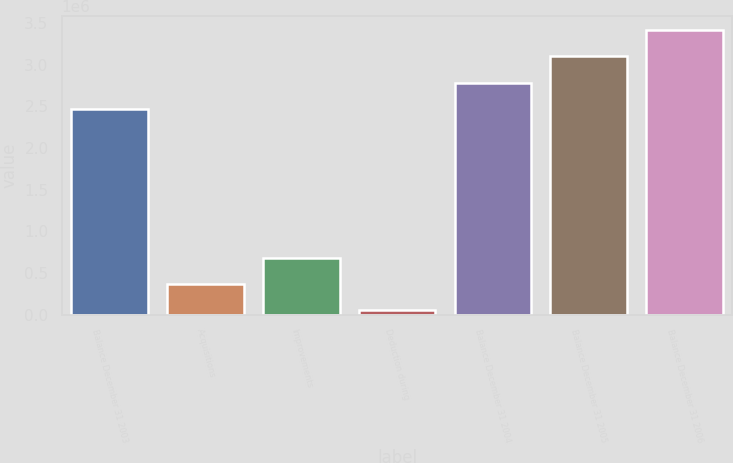<chart> <loc_0><loc_0><loc_500><loc_500><bar_chart><fcel>Balance December 31 2003<fcel>Acquisitions<fcel>Improvements<fcel>Deduction during<fcel>Balance December 31 2004<fcel>Balance December 31 2005<fcel>Balance December 31 2006<nl><fcel>2.47015e+06<fcel>368959<fcel>683992<fcel>53926<fcel>2.78518e+06<fcel>3.10022e+06<fcel>3.41525e+06<nl></chart> 